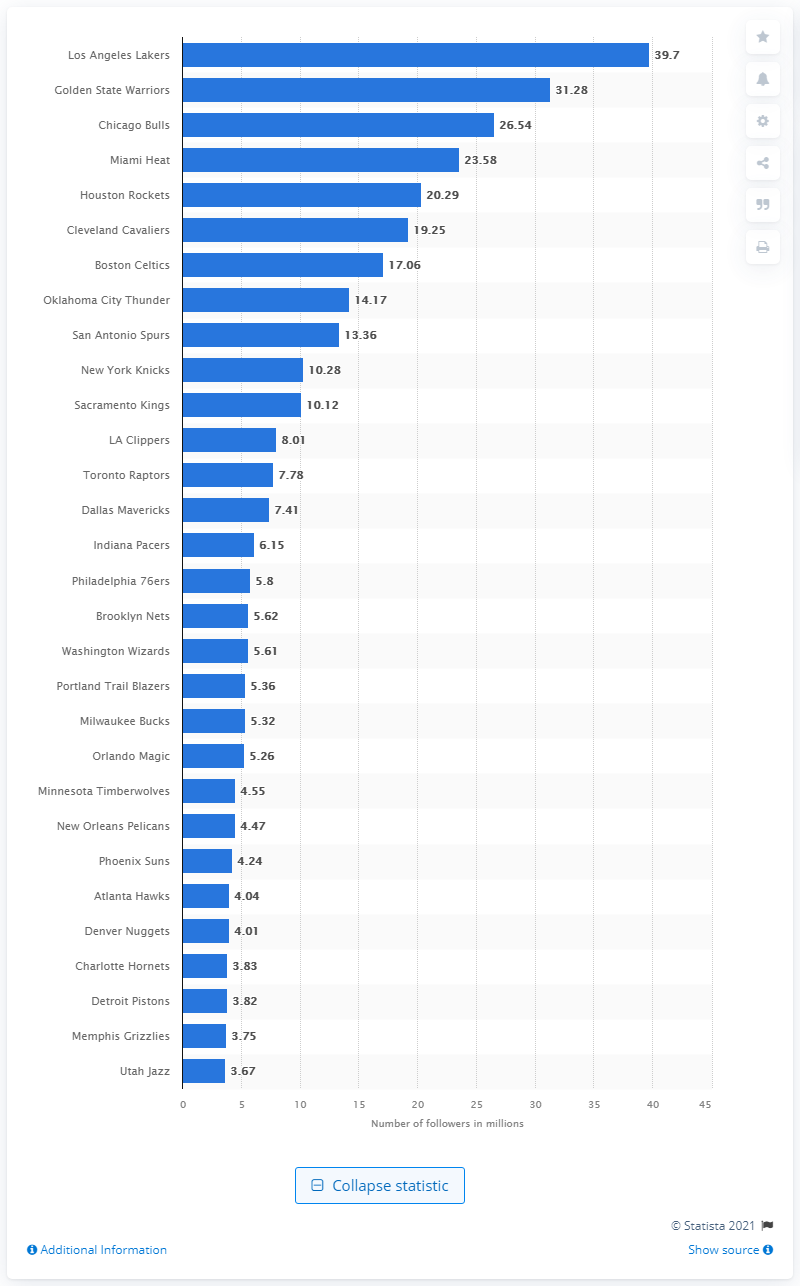Point out several critical features in this image. In 2019, the Los Angeles Lakers had a total of 39.7 followers. 